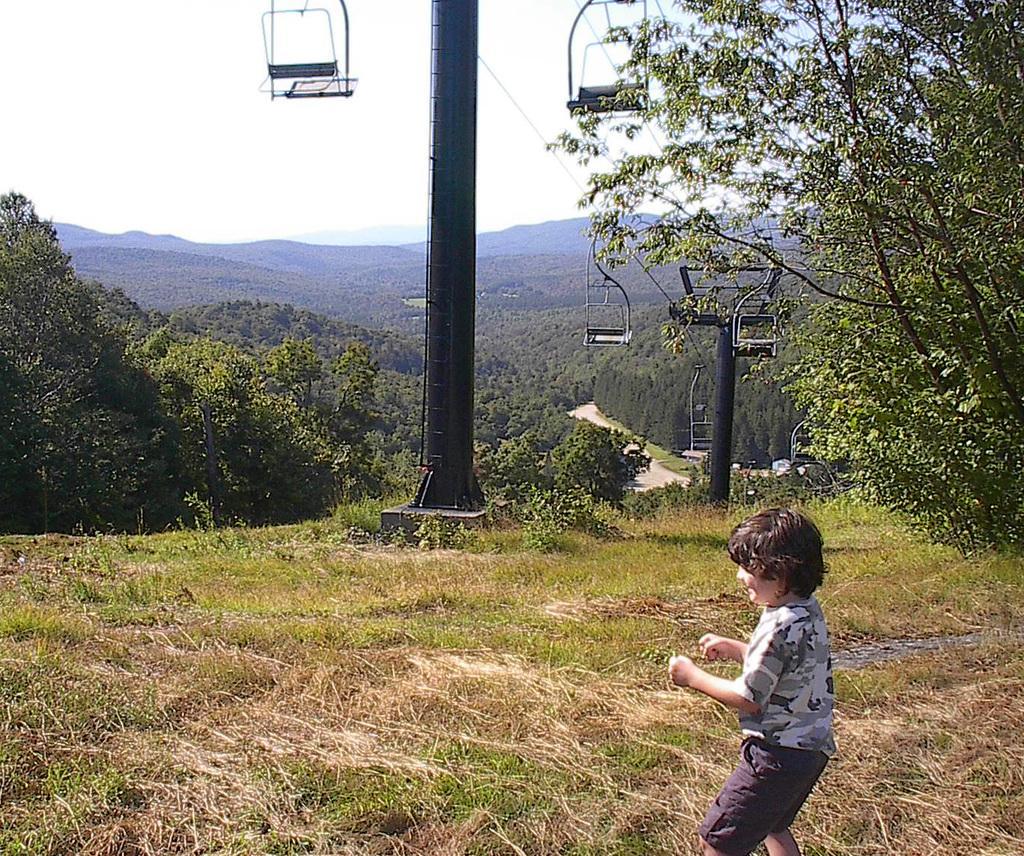Please provide a concise description of this image. Here we can see a children standing on the grass. There are cable cars, poles, plants, and trees. In the background there is sky. 